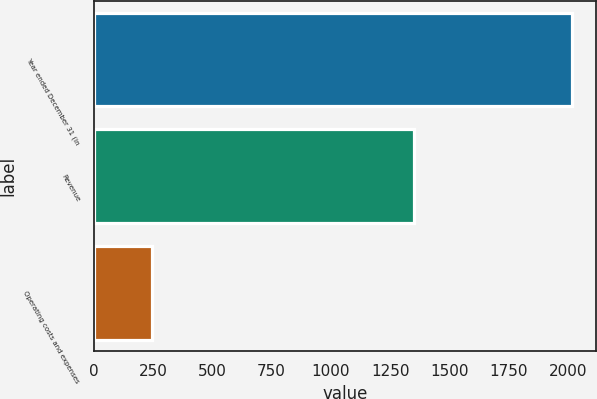Convert chart to OTSL. <chart><loc_0><loc_0><loc_500><loc_500><bar_chart><fcel>Year ended December 31 (in<fcel>Revenue<fcel>Operating costs and expenses<nl><fcel>2015<fcel>1349<fcel>246<nl></chart> 